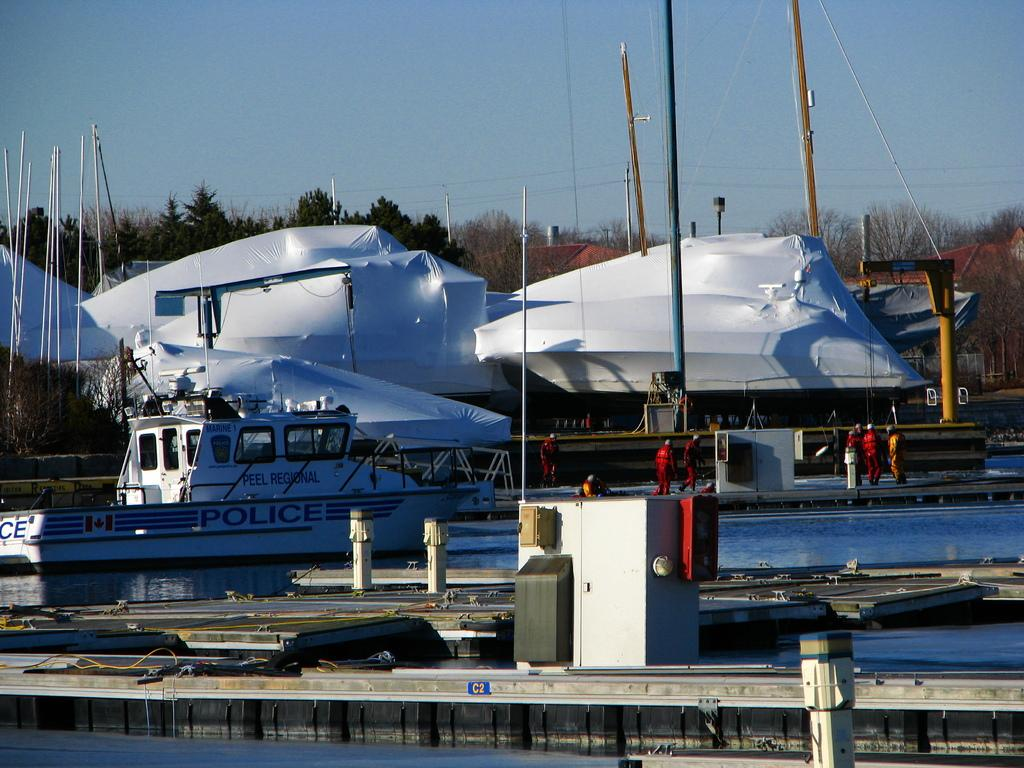<image>
Describe the image concisely. a boat that has the word police on the side 